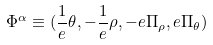Convert formula to latex. <formula><loc_0><loc_0><loc_500><loc_500>\Phi ^ { \alpha } \equiv ( \frac { 1 } { e } \theta , - \frac { 1 } { e } \rho , - e \Pi _ { \rho } , e \Pi _ { \theta } )</formula> 